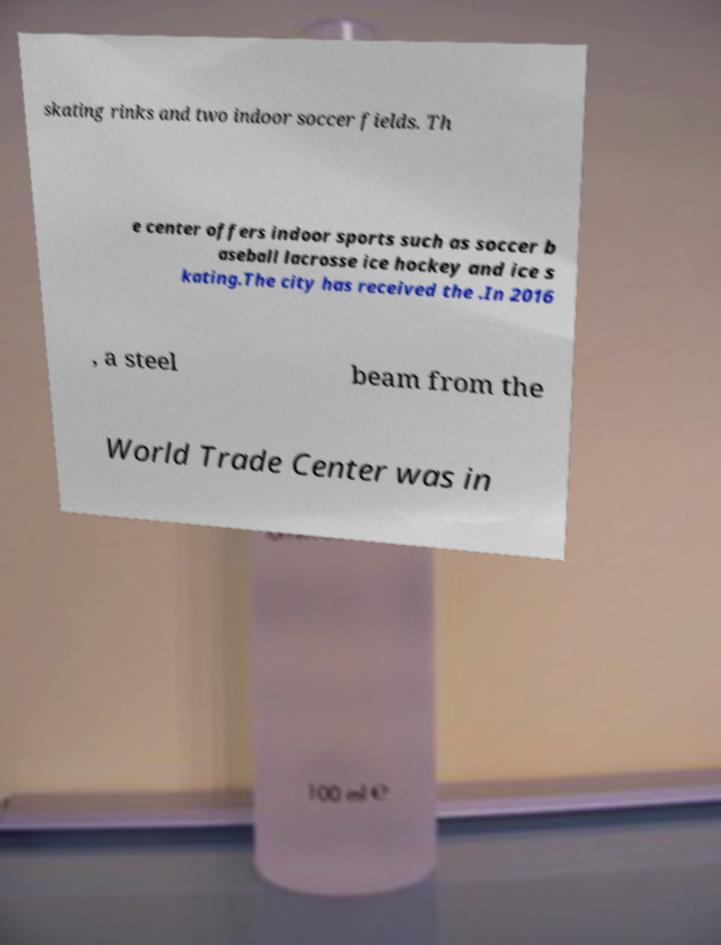Could you extract and type out the text from this image? skating rinks and two indoor soccer fields. Th e center offers indoor sports such as soccer b aseball lacrosse ice hockey and ice s kating.The city has received the .In 2016 , a steel beam from the World Trade Center was in 